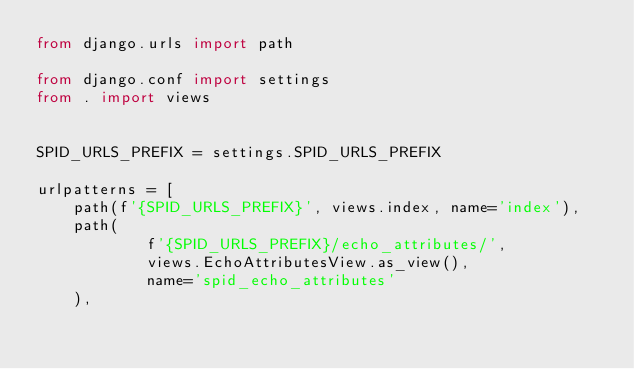<code> <loc_0><loc_0><loc_500><loc_500><_Python_>from django.urls import path

from django.conf import settings
from . import views


SPID_URLS_PREFIX = settings.SPID_URLS_PREFIX

urlpatterns = [
    path(f'{SPID_URLS_PREFIX}', views.index, name='index'),
    path(
            f'{SPID_URLS_PREFIX}/echo_attributes/',
            views.EchoAttributesView.as_view(),
            name='spid_echo_attributes'
    ),</code> 